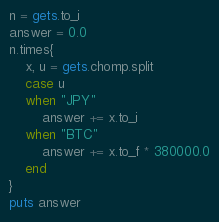Convert code to text. <code><loc_0><loc_0><loc_500><loc_500><_Ruby_>n = gets.to_i
answer = 0.0
n.times{
    x, u = gets.chomp.split
    case u
    when "JPY"
        answer += x.to_i
    when "BTC"
        answer += x.to_f * 380000.0
    end
}
puts answer</code> 